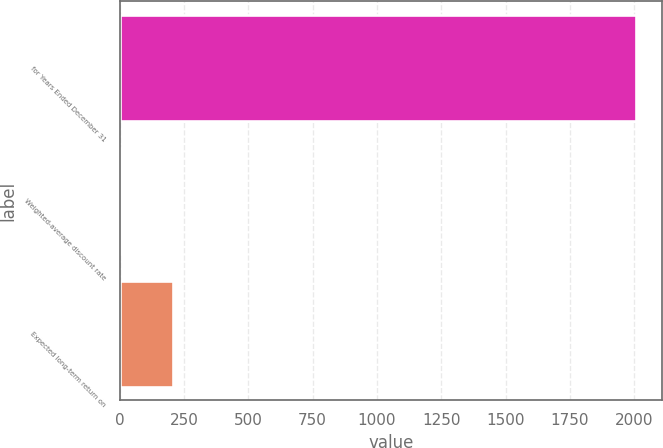<chart> <loc_0><loc_0><loc_500><loc_500><bar_chart><fcel>for Years Ended December 31<fcel>Weighted-average discount rate<fcel>Expected long-term return on<nl><fcel>2009<fcel>7<fcel>207.2<nl></chart> 